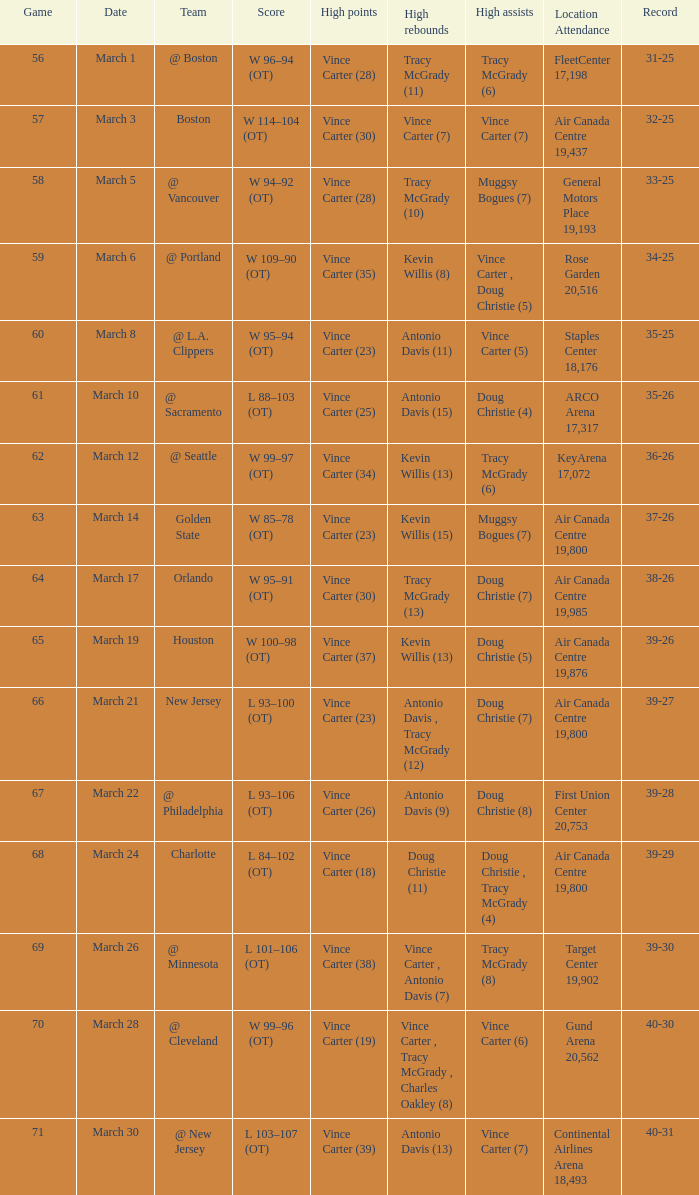Who was the high rebounder against charlotte? Doug Christie (11). 